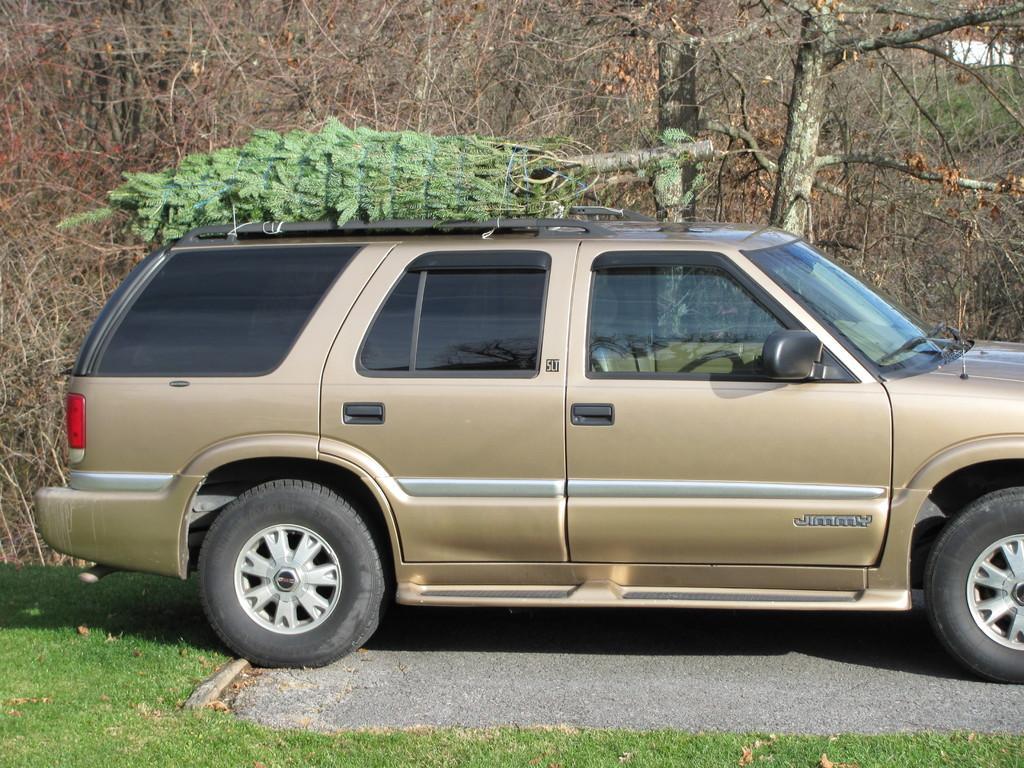Can you describe this image briefly? In this image in the center there is one car and in the background there are some trees, at the bottom there is grass and road. 